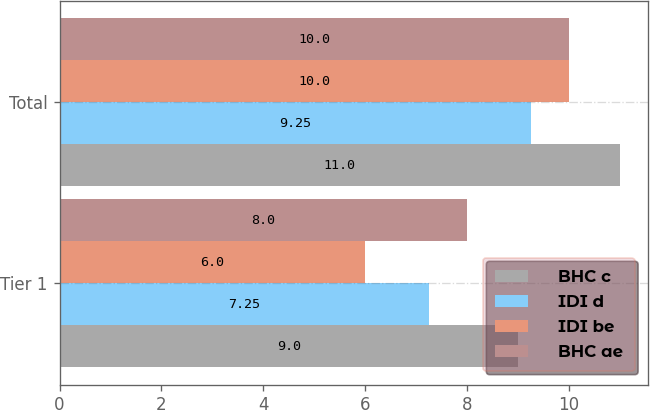<chart> <loc_0><loc_0><loc_500><loc_500><stacked_bar_chart><ecel><fcel>Tier 1<fcel>Total<nl><fcel>BHC c<fcel>9<fcel>11<nl><fcel>IDI d<fcel>7.25<fcel>9.25<nl><fcel>IDI be<fcel>6<fcel>10<nl><fcel>BHC ae<fcel>8<fcel>10<nl></chart> 